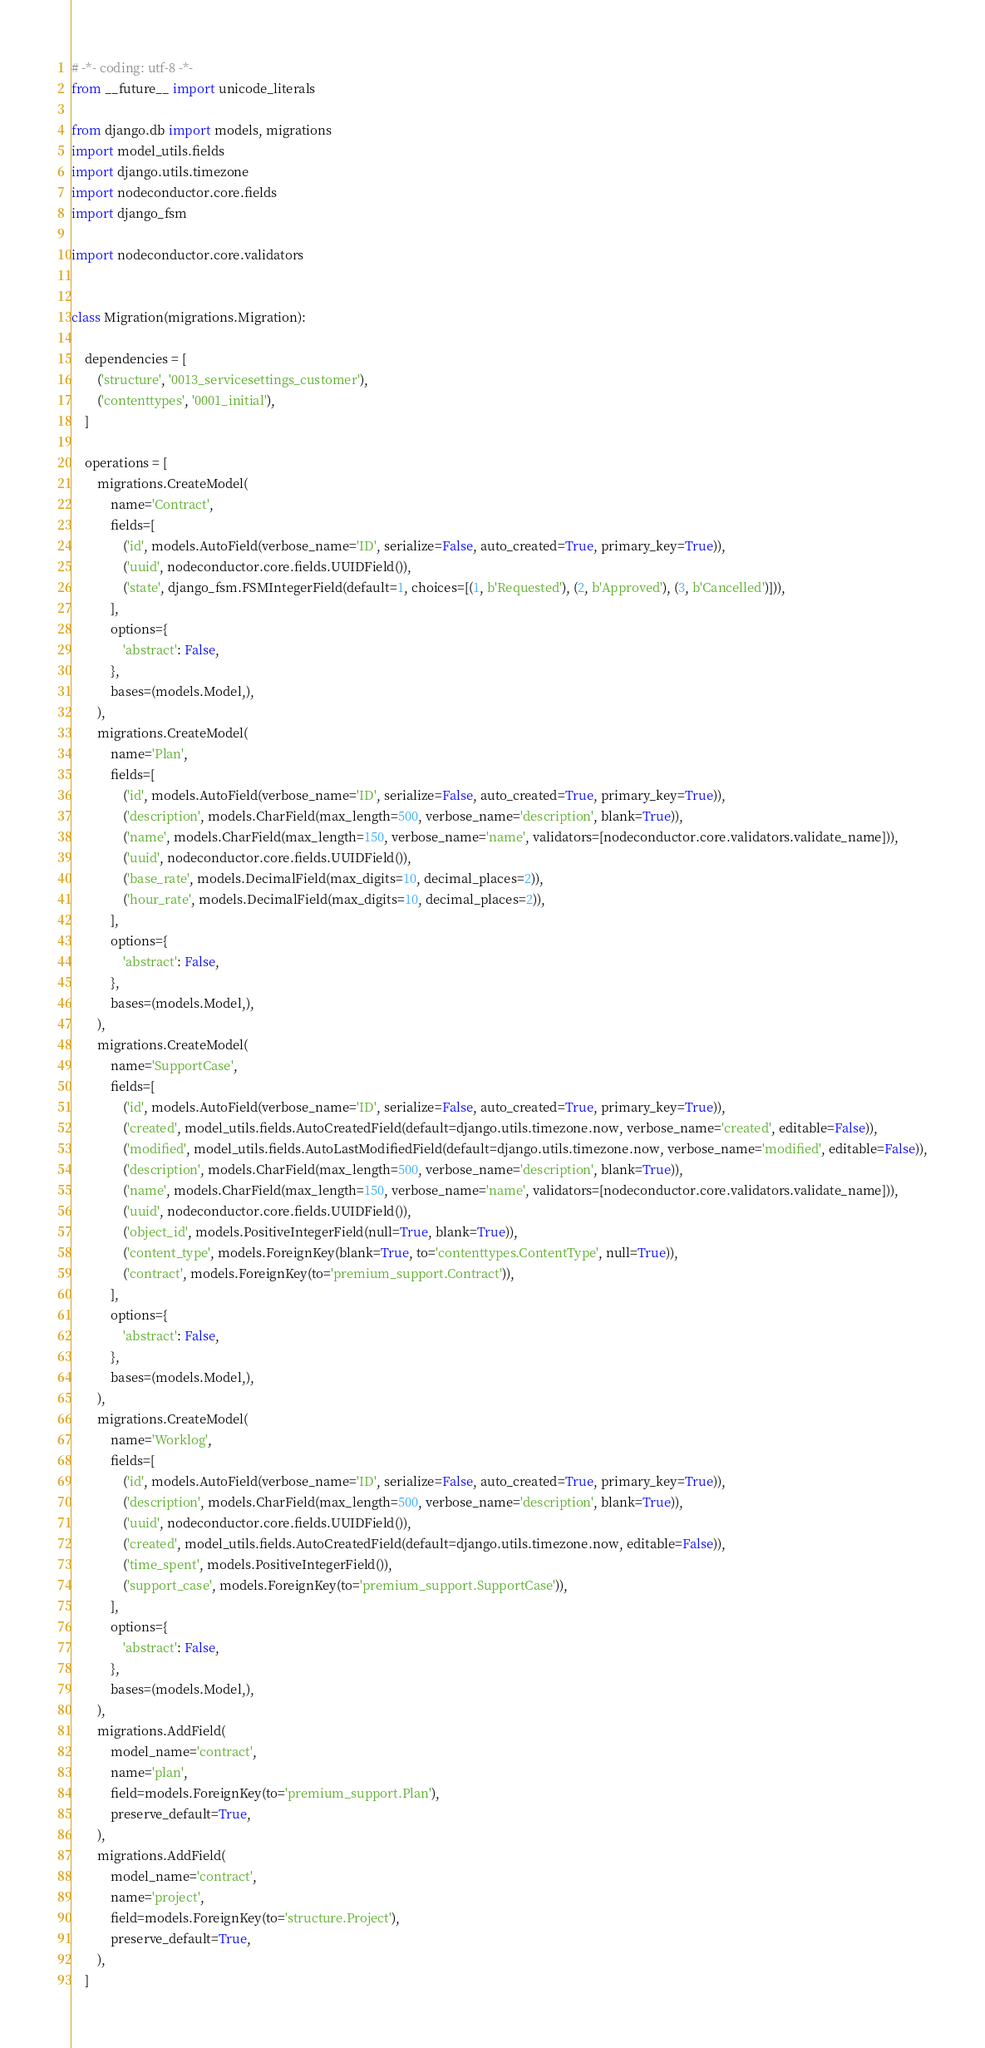Convert code to text. <code><loc_0><loc_0><loc_500><loc_500><_Python_># -*- coding: utf-8 -*-
from __future__ import unicode_literals

from django.db import models, migrations
import model_utils.fields
import django.utils.timezone
import nodeconductor.core.fields
import django_fsm

import nodeconductor.core.validators


class Migration(migrations.Migration):

    dependencies = [
        ('structure', '0013_servicesettings_customer'),
        ('contenttypes', '0001_initial'),
    ]

    operations = [
        migrations.CreateModel(
            name='Contract',
            fields=[
                ('id', models.AutoField(verbose_name='ID', serialize=False, auto_created=True, primary_key=True)),
                ('uuid', nodeconductor.core.fields.UUIDField()),
                ('state', django_fsm.FSMIntegerField(default=1, choices=[(1, b'Requested'), (2, b'Approved'), (3, b'Cancelled')])),
            ],
            options={
                'abstract': False,
            },
            bases=(models.Model,),
        ),
        migrations.CreateModel(
            name='Plan',
            fields=[
                ('id', models.AutoField(verbose_name='ID', serialize=False, auto_created=True, primary_key=True)),
                ('description', models.CharField(max_length=500, verbose_name='description', blank=True)),
                ('name', models.CharField(max_length=150, verbose_name='name', validators=[nodeconductor.core.validators.validate_name])),
                ('uuid', nodeconductor.core.fields.UUIDField()),
                ('base_rate', models.DecimalField(max_digits=10, decimal_places=2)),
                ('hour_rate', models.DecimalField(max_digits=10, decimal_places=2)),
            ],
            options={
                'abstract': False,
            },
            bases=(models.Model,),
        ),
        migrations.CreateModel(
            name='SupportCase',
            fields=[
                ('id', models.AutoField(verbose_name='ID', serialize=False, auto_created=True, primary_key=True)),
                ('created', model_utils.fields.AutoCreatedField(default=django.utils.timezone.now, verbose_name='created', editable=False)),
                ('modified', model_utils.fields.AutoLastModifiedField(default=django.utils.timezone.now, verbose_name='modified', editable=False)),
                ('description', models.CharField(max_length=500, verbose_name='description', blank=True)),
                ('name', models.CharField(max_length=150, verbose_name='name', validators=[nodeconductor.core.validators.validate_name])),
                ('uuid', nodeconductor.core.fields.UUIDField()),
                ('object_id', models.PositiveIntegerField(null=True, blank=True)),
                ('content_type', models.ForeignKey(blank=True, to='contenttypes.ContentType', null=True)),
                ('contract', models.ForeignKey(to='premium_support.Contract')),
            ],
            options={
                'abstract': False,
            },
            bases=(models.Model,),
        ),
        migrations.CreateModel(
            name='Worklog',
            fields=[
                ('id', models.AutoField(verbose_name='ID', serialize=False, auto_created=True, primary_key=True)),
                ('description', models.CharField(max_length=500, verbose_name='description', blank=True)),
                ('uuid', nodeconductor.core.fields.UUIDField()),
                ('created', model_utils.fields.AutoCreatedField(default=django.utils.timezone.now, editable=False)),
                ('time_spent', models.PositiveIntegerField()),
                ('support_case', models.ForeignKey(to='premium_support.SupportCase')),
            ],
            options={
                'abstract': False,
            },
            bases=(models.Model,),
        ),
        migrations.AddField(
            model_name='contract',
            name='plan',
            field=models.ForeignKey(to='premium_support.Plan'),
            preserve_default=True,
        ),
        migrations.AddField(
            model_name='contract',
            name='project',
            field=models.ForeignKey(to='structure.Project'),
            preserve_default=True,
        ),
    ]
</code> 